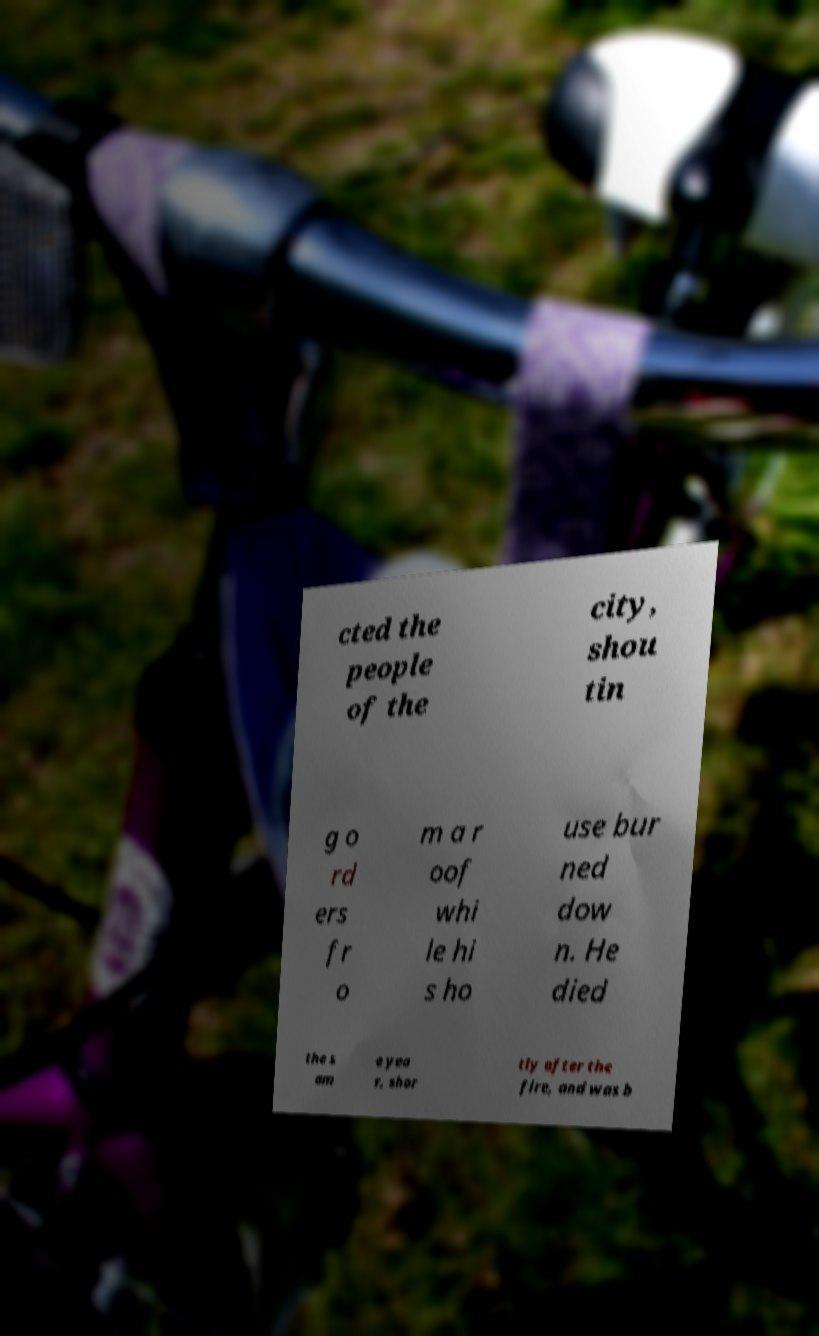For documentation purposes, I need the text within this image transcribed. Could you provide that? cted the people of the city, shou tin g o rd ers fr o m a r oof whi le hi s ho use bur ned dow n. He died the s am e yea r, shor tly after the fire, and was b 